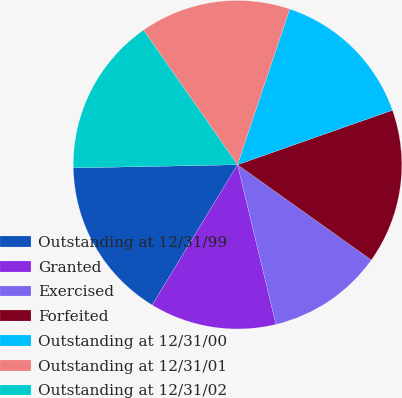Convert chart. <chart><loc_0><loc_0><loc_500><loc_500><pie_chart><fcel>Outstanding at 12/31/99<fcel>Granted<fcel>Exercised<fcel>Forfeited<fcel>Outstanding at 12/31/00<fcel>Outstanding at 12/31/01<fcel>Outstanding at 12/31/02<nl><fcel>15.99%<fcel>12.46%<fcel>11.4%<fcel>15.23%<fcel>14.47%<fcel>14.85%<fcel>15.61%<nl></chart> 